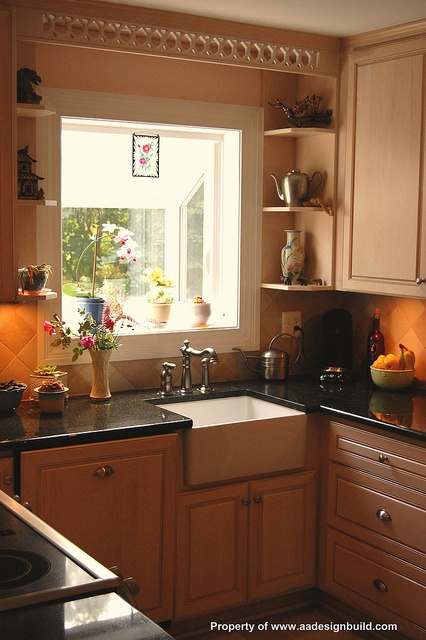Describe the objects in this image and their specific colors. I can see oven in maroon, black, beige, and gray tones, potted plant in maroon, ivory, brown, and gray tones, sink in maroon, tan, black, and lightgray tones, vase in maroon, brown, and gray tones, and vase in maroon, brown, gray, and tan tones in this image. 